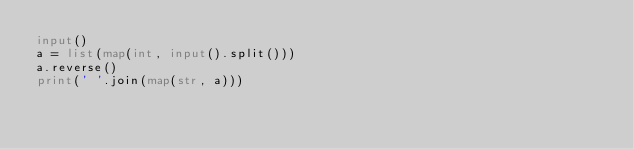Convert code to text. <code><loc_0><loc_0><loc_500><loc_500><_Python_>input()
a = list(map(int, input().split()))
a.reverse()
print(' '.join(map(str, a)))
</code> 